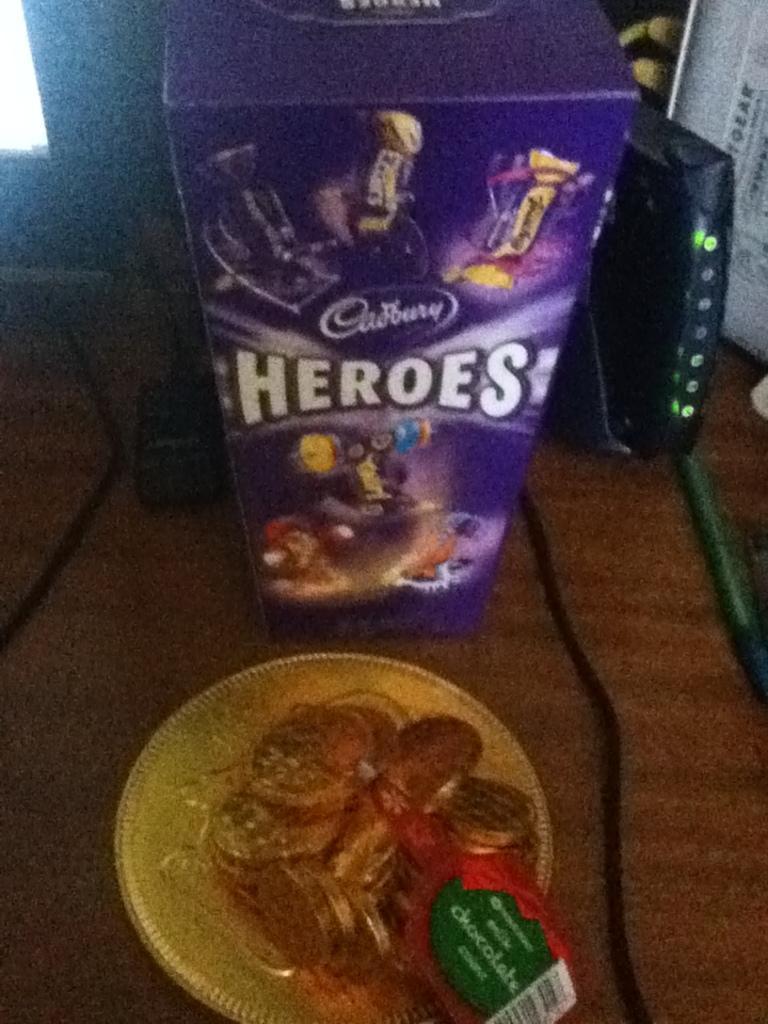How would you summarize this image in a sentence or two? In this image there is a box in the center with some text written on it. In front of the box there is an object which is Golden in colour and there are wires on the table. On the right side there is adapter and there is a white colour object. 